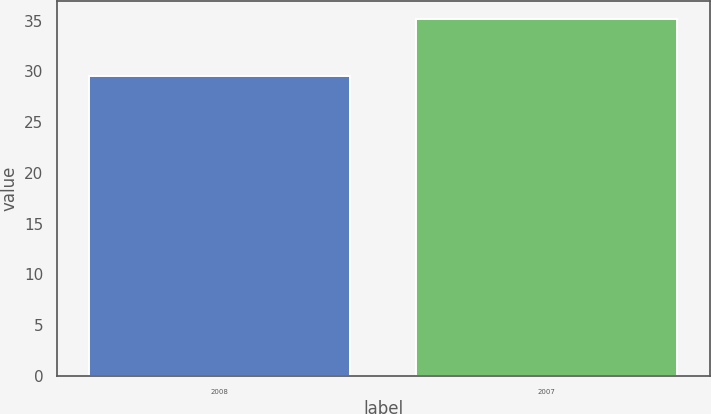<chart> <loc_0><loc_0><loc_500><loc_500><bar_chart><fcel>2008<fcel>2007<nl><fcel>29.52<fcel>35.2<nl></chart> 